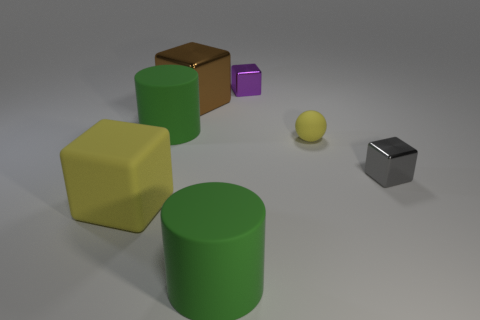There is a thing that is right of the brown thing and behind the yellow matte ball; what is its color?
Offer a terse response. Purple. Do the yellow matte thing to the left of the matte sphere and the yellow matte ball have the same size?
Provide a succinct answer. No. Is the number of large cubes that are to the left of the big brown metallic block greater than the number of green rubber cylinders?
Make the answer very short. No. Does the big yellow thing have the same shape as the purple thing?
Give a very brief answer. Yes. What size is the matte block?
Your response must be concise. Large. Is the number of small cubes that are in front of the big yellow block greater than the number of large yellow things right of the large brown object?
Offer a very short reply. No. Are there any gray objects to the left of the tiny rubber thing?
Provide a short and direct response. No. Are there any purple cubes that have the same size as the gray metallic thing?
Keep it short and to the point. Yes. What is the color of the other small object that is made of the same material as the gray object?
Your answer should be very brief. Purple. What is the gray block made of?
Offer a terse response. Metal. 